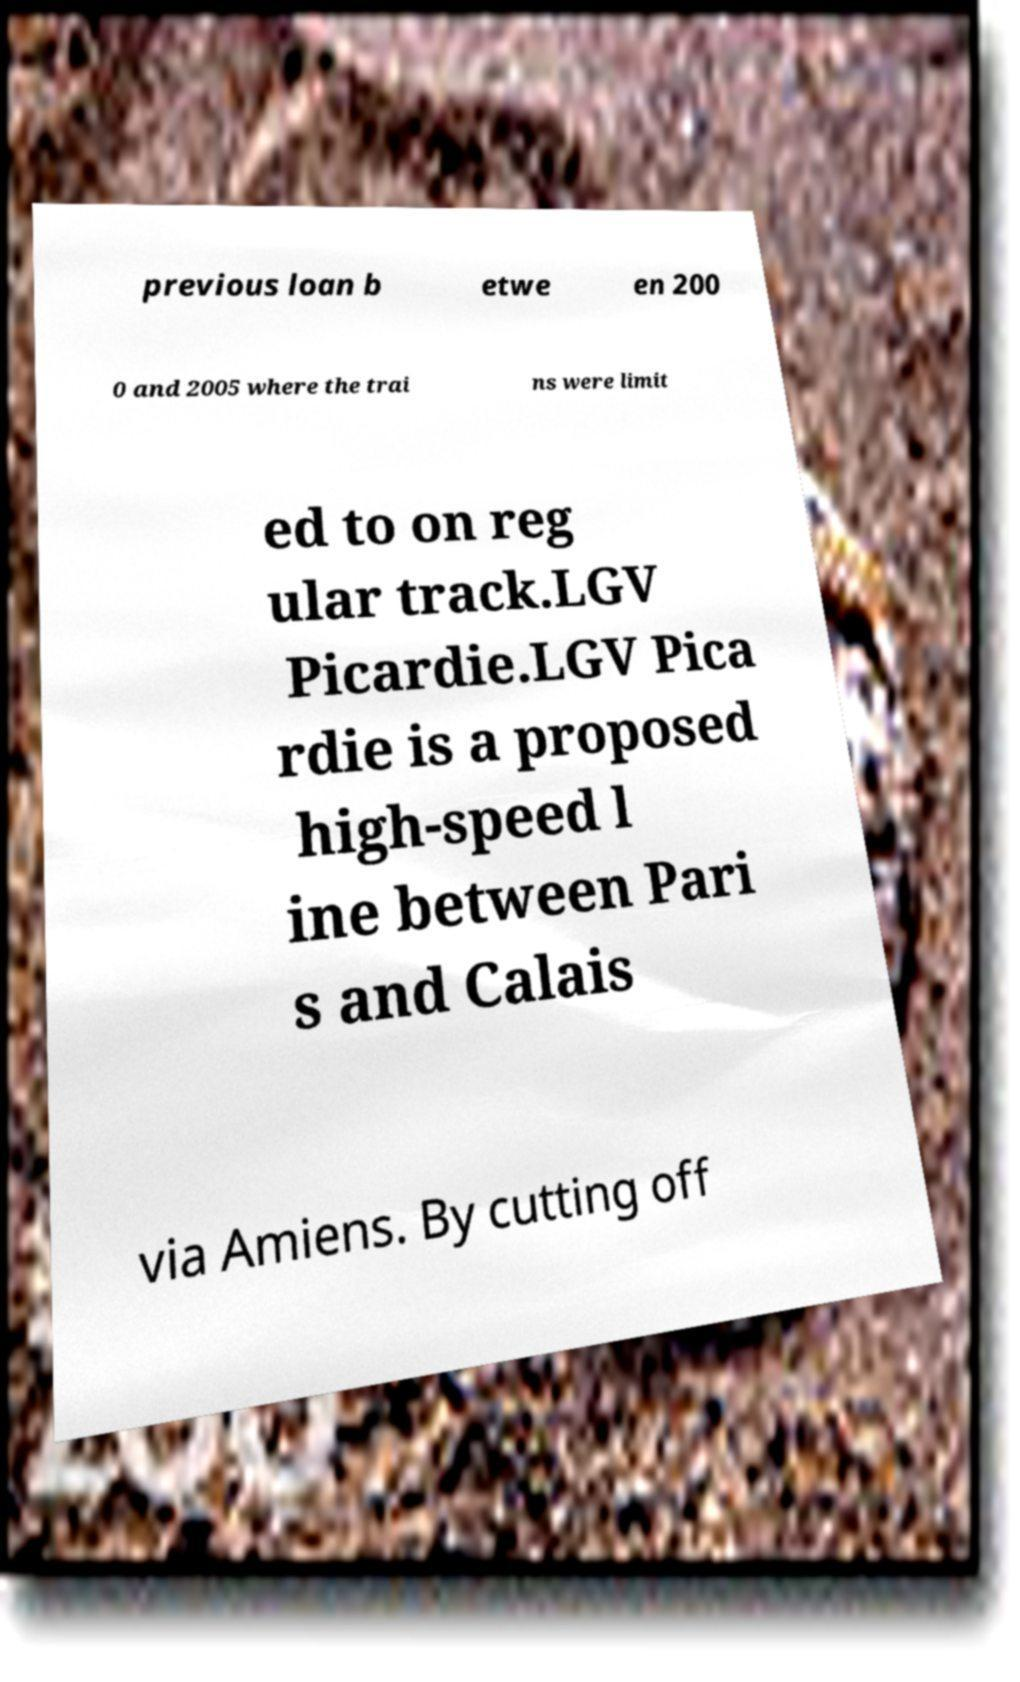For documentation purposes, I need the text within this image transcribed. Could you provide that? previous loan b etwe en 200 0 and 2005 where the trai ns were limit ed to on reg ular track.LGV Picardie.LGV Pica rdie is a proposed high-speed l ine between Pari s and Calais via Amiens. By cutting off 